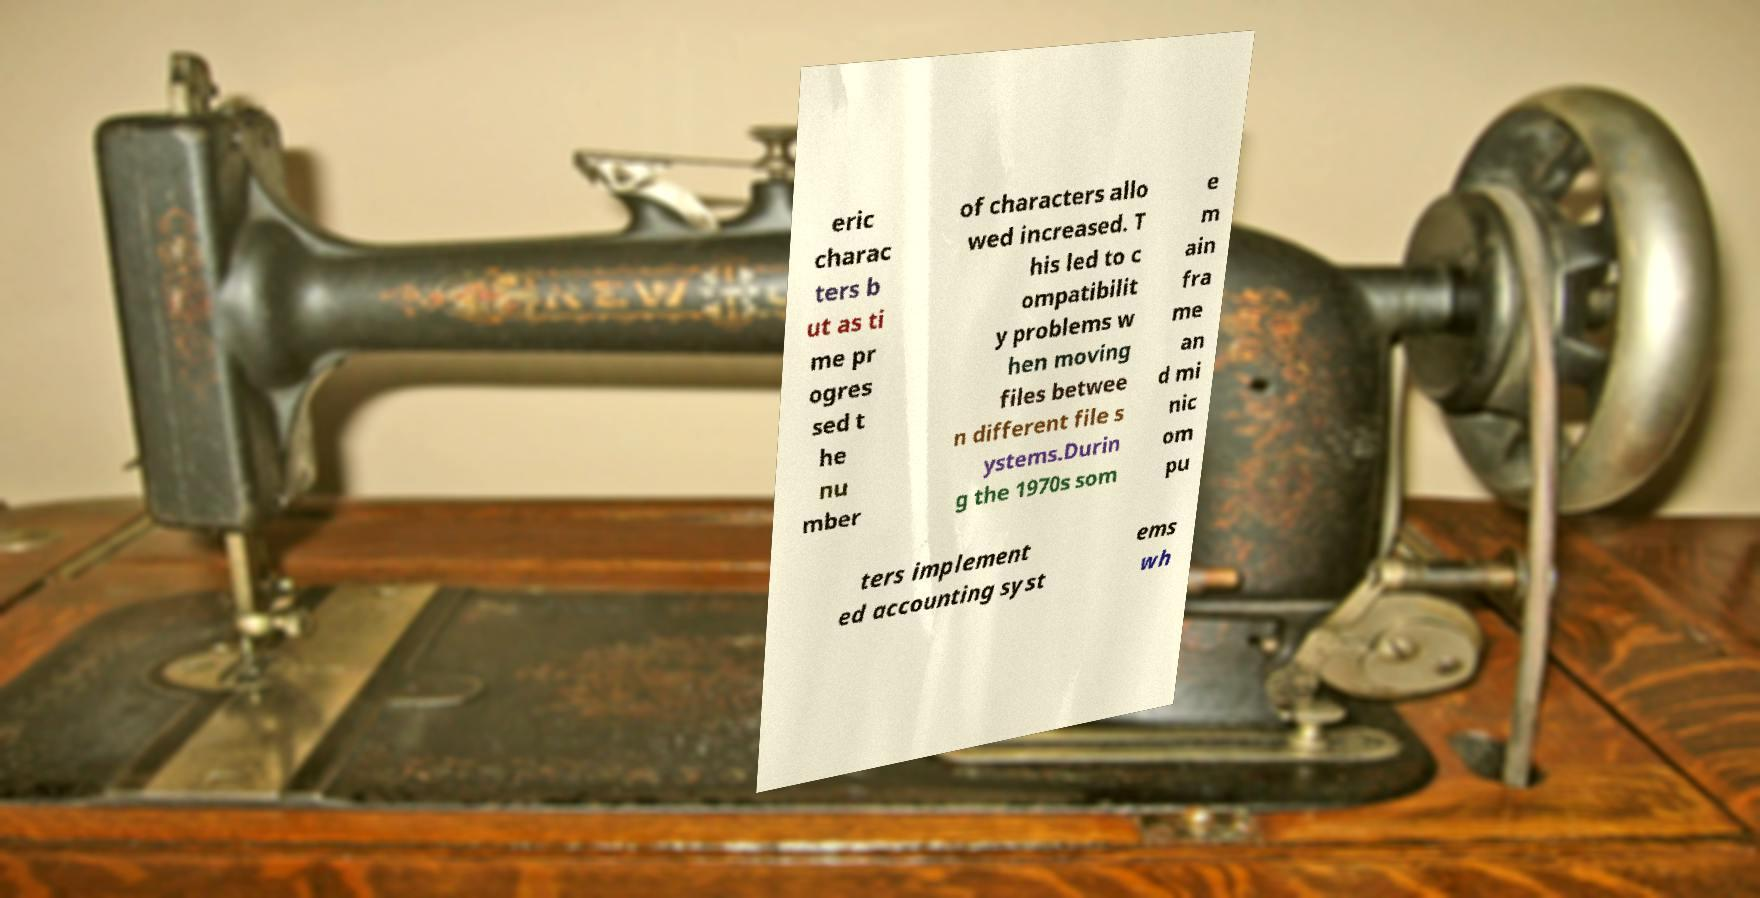Could you assist in decoding the text presented in this image and type it out clearly? eric charac ters b ut as ti me pr ogres sed t he nu mber of characters allo wed increased. T his led to c ompatibilit y problems w hen moving files betwee n different file s ystems.Durin g the 1970s som e m ain fra me an d mi nic om pu ters implement ed accounting syst ems wh 